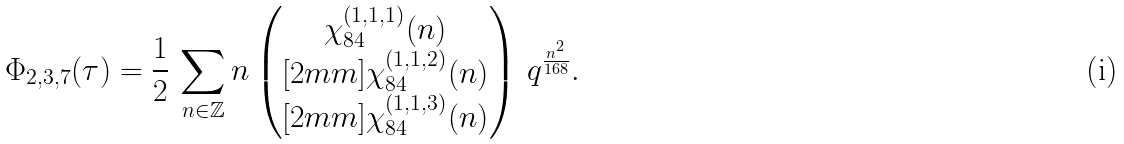<formula> <loc_0><loc_0><loc_500><loc_500>\Phi _ { 2 , 3 , 7 } ( \tau ) = \frac { 1 } { 2 } \, \sum _ { n \in \mathbb { Z } } n \begin{pmatrix} \chi _ { 8 4 } ^ { ( 1 , 1 , 1 ) } ( n ) \\ [ 2 m m ] \chi _ { 8 4 } ^ { ( 1 , 1 , 2 ) } ( n ) \\ [ 2 m m ] \chi _ { 8 4 } ^ { ( 1 , 1 , 3 ) } ( n ) \end{pmatrix} \, q ^ { \frac { n ^ { 2 } } { 1 6 8 } } .</formula> 